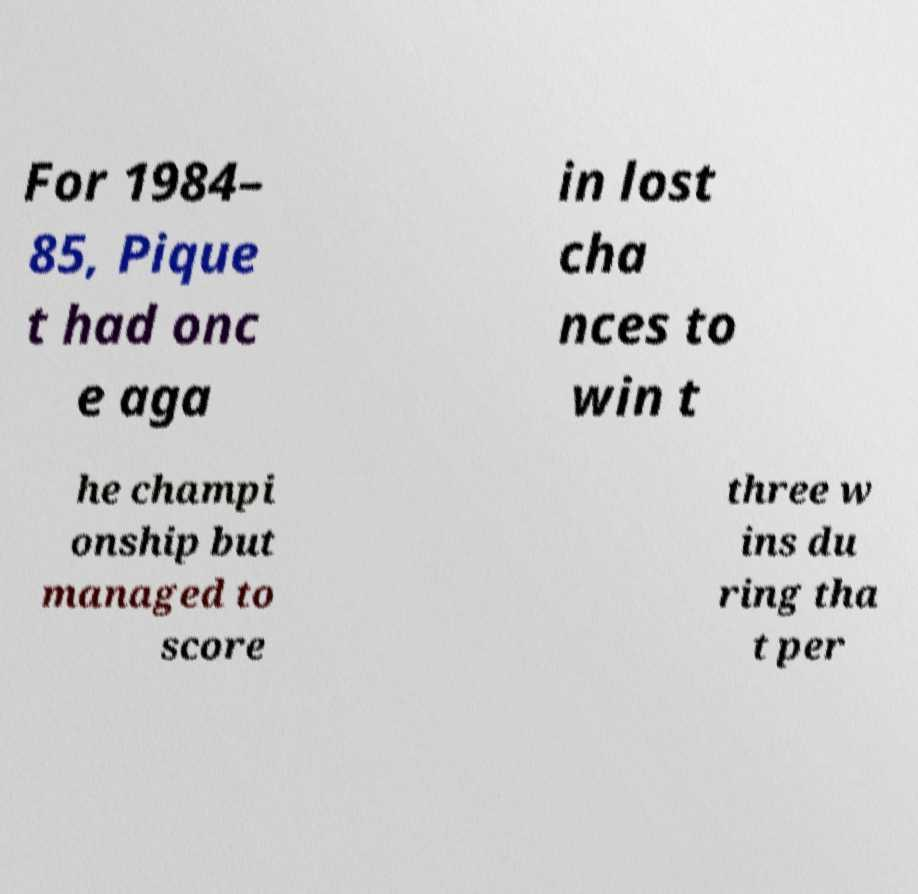Could you extract and type out the text from this image? For 1984– 85, Pique t had onc e aga in lost cha nces to win t he champi onship but managed to score three w ins du ring tha t per 